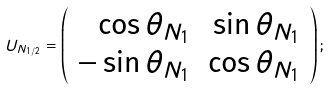Convert formula to latex. <formula><loc_0><loc_0><loc_500><loc_500>U _ { N _ { 1 / 2 } } = \left ( \begin{array} { r r } { { \cos \theta _ { N _ { 1 } } } } & { { \sin \theta _ { N _ { 1 } } } } \\ { { - \sin \theta _ { N _ { 1 } } } } & { { \cos \theta _ { N _ { 1 } } } } \end{array} \right ) ;</formula> 